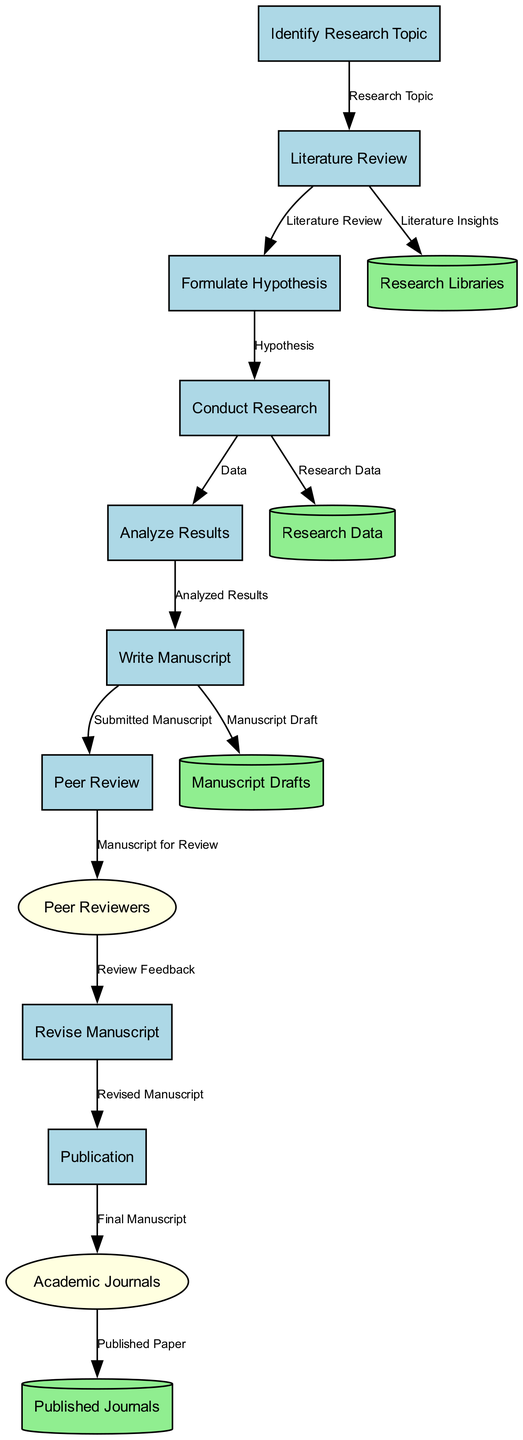What is the first process in the publication process? The first process listed in the diagram is "Identify Research Topic," which is the starting point for the mathematician's research activities.
Answer: Identify Research Topic How many data stores are present in the diagram? There are four data stores shown in the diagram, each representing a different collection of information relevant to the research process.
Answer: 4 What follows the "Literature Review" process? The process that follows "Literature Review" is "Formulate Hypothesis," indicating the sequential flow from reviewing literature to developing a research hypothesis.
Answer: Formulate Hypothesis Who provides feedback during the peer review process? The external entity that provides feedback during the peer review process is "Peer Reviewers." This indicates their role in evaluating the manuscript before publication.
Answer: Peer Reviewers Which data store contains draft versions of research papers? The data store that contains draft versions of research papers is "Manuscript Drafts," which is specifically dedicated to storing various drafts prepared by the mathematician.
Answer: Manuscript Drafts What is the relationship between "Analyze Results" and "Write Manuscript"? The "Analyze Results" process leads into the "Write Manuscript" process, as the conclusions drawn from analyzing results are essential for writing the research paper.
Answer: Analyze Results → Write Manuscript What is the last step in the process before publication? The last step before publication is "Revise Manuscript," where the mathematician makes necessary revisions based on peer feedback received during the review process.
Answer: Revise Manuscript How many peer review steps are involved according to the diagram? There are two steps involving peer review: the submission of the manuscript for review and the subsequent revisions based on the feedback, indicating an iterative review process.
Answer: 2 What type of journal receives the final manuscript? The type of journal that receives the final manuscript is "Academic Journals," highlighting their role in publishing the mathematician's findings.
Answer: Academic Journals 